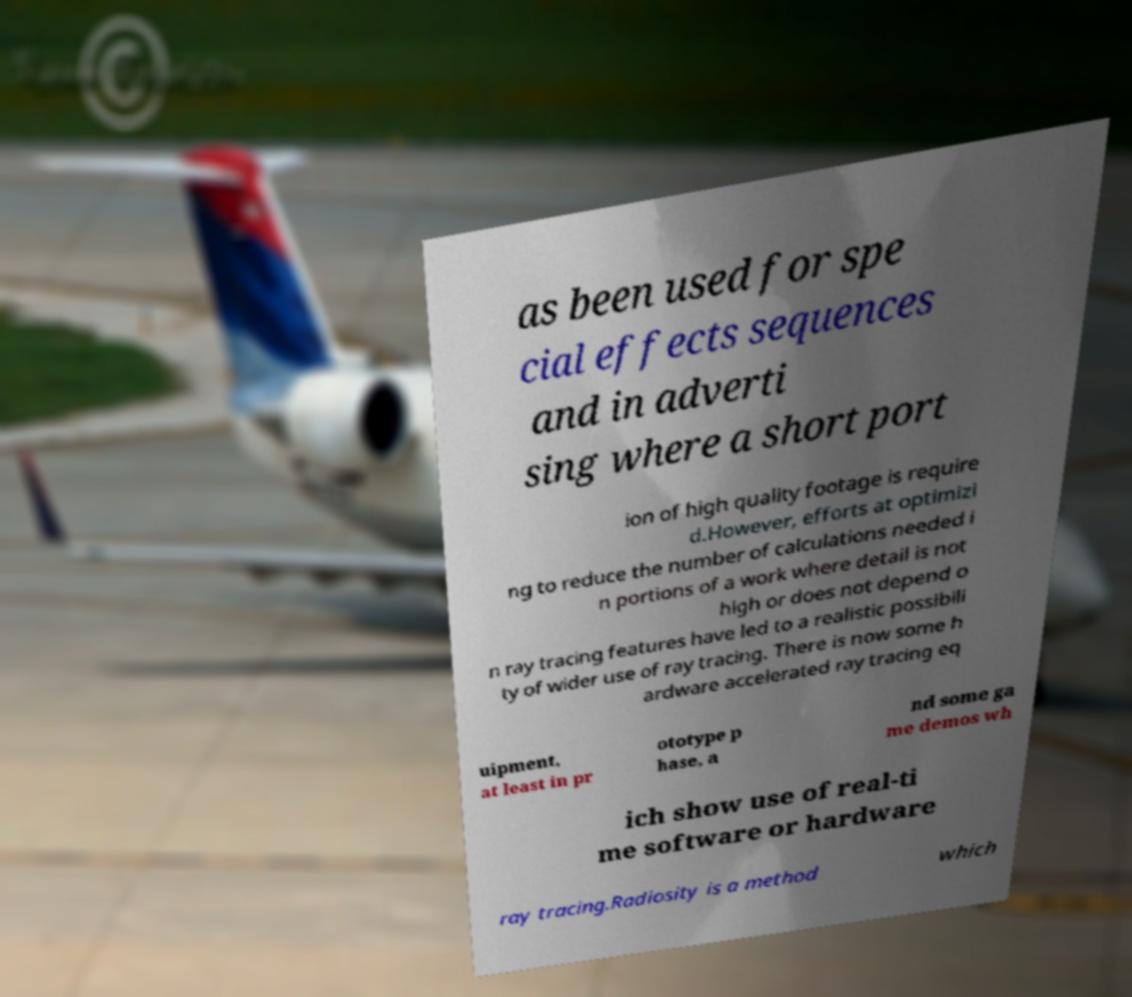Please identify and transcribe the text found in this image. as been used for spe cial effects sequences and in adverti sing where a short port ion of high quality footage is require d.However, efforts at optimizi ng to reduce the number of calculations needed i n portions of a work where detail is not high or does not depend o n ray tracing features have led to a realistic possibili ty of wider use of ray tracing. There is now some h ardware accelerated ray tracing eq uipment, at least in pr ototype p hase, a nd some ga me demos wh ich show use of real-ti me software or hardware ray tracing.Radiosity is a method which 